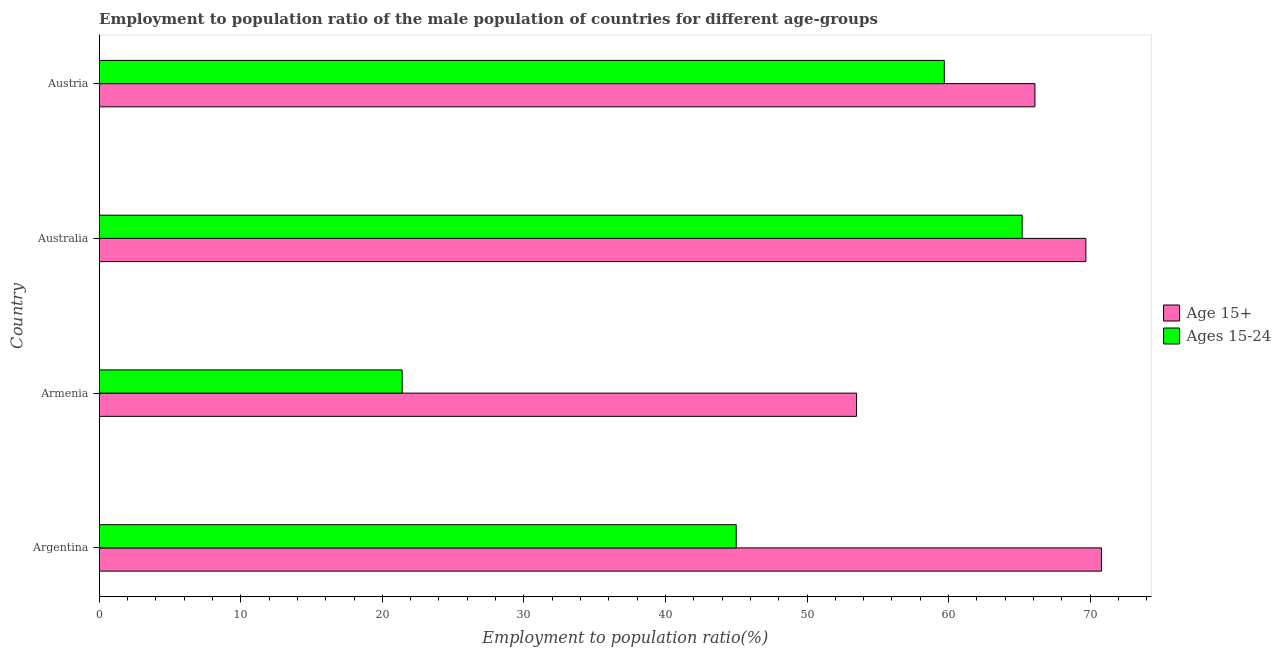Are the number of bars per tick equal to the number of legend labels?
Offer a terse response. Yes. What is the employment to population ratio(age 15-24) in Armenia?
Your answer should be compact. 21.4. Across all countries, what is the maximum employment to population ratio(age 15-24)?
Offer a very short reply. 65.2. Across all countries, what is the minimum employment to population ratio(age 15+)?
Your response must be concise. 53.5. In which country was the employment to population ratio(age 15-24) minimum?
Ensure brevity in your answer.  Armenia. What is the total employment to population ratio(age 15+) in the graph?
Ensure brevity in your answer.  260.1. What is the difference between the employment to population ratio(age 15+) in Armenia and that in Australia?
Give a very brief answer. -16.2. What is the average employment to population ratio(age 15-24) per country?
Offer a terse response. 47.83. What is the difference between the employment to population ratio(age 15-24) and employment to population ratio(age 15+) in Australia?
Your answer should be compact. -4.5. What is the ratio of the employment to population ratio(age 15-24) in Australia to that in Austria?
Provide a succinct answer. 1.09. Is the employment to population ratio(age 15-24) in Argentina less than that in Armenia?
Your answer should be compact. No. Is the difference between the employment to population ratio(age 15+) in Armenia and Australia greater than the difference between the employment to population ratio(age 15-24) in Armenia and Australia?
Your answer should be very brief. Yes. What is the difference between the highest and the second highest employment to population ratio(age 15+)?
Your answer should be compact. 1.1. What is the difference between the highest and the lowest employment to population ratio(age 15-24)?
Your answer should be very brief. 43.8. In how many countries, is the employment to population ratio(age 15-24) greater than the average employment to population ratio(age 15-24) taken over all countries?
Offer a very short reply. 2. Is the sum of the employment to population ratio(age 15+) in Argentina and Australia greater than the maximum employment to population ratio(age 15-24) across all countries?
Give a very brief answer. Yes. What does the 2nd bar from the top in Argentina represents?
Keep it short and to the point. Age 15+. What does the 2nd bar from the bottom in Argentina represents?
Keep it short and to the point. Ages 15-24. How many bars are there?
Your answer should be compact. 8. Are all the bars in the graph horizontal?
Your answer should be very brief. Yes. How many countries are there in the graph?
Your answer should be compact. 4. What is the difference between two consecutive major ticks on the X-axis?
Your response must be concise. 10. Are the values on the major ticks of X-axis written in scientific E-notation?
Your answer should be very brief. No. Does the graph contain any zero values?
Your answer should be very brief. No. Does the graph contain grids?
Ensure brevity in your answer.  No. How many legend labels are there?
Your answer should be very brief. 2. What is the title of the graph?
Your answer should be very brief. Employment to population ratio of the male population of countries for different age-groups. Does "Working capital" appear as one of the legend labels in the graph?
Your response must be concise. No. What is the label or title of the X-axis?
Your response must be concise. Employment to population ratio(%). What is the label or title of the Y-axis?
Make the answer very short. Country. What is the Employment to population ratio(%) in Age 15+ in Argentina?
Offer a very short reply. 70.8. What is the Employment to population ratio(%) in Ages 15-24 in Argentina?
Provide a short and direct response. 45. What is the Employment to population ratio(%) of Age 15+ in Armenia?
Give a very brief answer. 53.5. What is the Employment to population ratio(%) in Ages 15-24 in Armenia?
Make the answer very short. 21.4. What is the Employment to population ratio(%) of Age 15+ in Australia?
Make the answer very short. 69.7. What is the Employment to population ratio(%) in Ages 15-24 in Australia?
Ensure brevity in your answer.  65.2. What is the Employment to population ratio(%) in Age 15+ in Austria?
Your response must be concise. 66.1. What is the Employment to population ratio(%) of Ages 15-24 in Austria?
Your answer should be compact. 59.7. Across all countries, what is the maximum Employment to population ratio(%) in Age 15+?
Offer a terse response. 70.8. Across all countries, what is the maximum Employment to population ratio(%) in Ages 15-24?
Ensure brevity in your answer.  65.2. Across all countries, what is the minimum Employment to population ratio(%) in Age 15+?
Provide a succinct answer. 53.5. Across all countries, what is the minimum Employment to population ratio(%) of Ages 15-24?
Provide a short and direct response. 21.4. What is the total Employment to population ratio(%) in Age 15+ in the graph?
Provide a short and direct response. 260.1. What is the total Employment to population ratio(%) in Ages 15-24 in the graph?
Your response must be concise. 191.3. What is the difference between the Employment to population ratio(%) of Ages 15-24 in Argentina and that in Armenia?
Provide a short and direct response. 23.6. What is the difference between the Employment to population ratio(%) of Ages 15-24 in Argentina and that in Australia?
Keep it short and to the point. -20.2. What is the difference between the Employment to population ratio(%) of Age 15+ in Argentina and that in Austria?
Ensure brevity in your answer.  4.7. What is the difference between the Employment to population ratio(%) in Ages 15-24 in Argentina and that in Austria?
Provide a succinct answer. -14.7. What is the difference between the Employment to population ratio(%) of Age 15+ in Armenia and that in Australia?
Your answer should be very brief. -16.2. What is the difference between the Employment to population ratio(%) in Ages 15-24 in Armenia and that in Australia?
Keep it short and to the point. -43.8. What is the difference between the Employment to population ratio(%) of Age 15+ in Armenia and that in Austria?
Give a very brief answer. -12.6. What is the difference between the Employment to population ratio(%) in Ages 15-24 in Armenia and that in Austria?
Provide a succinct answer. -38.3. What is the difference between the Employment to population ratio(%) of Age 15+ in Argentina and the Employment to population ratio(%) of Ages 15-24 in Armenia?
Make the answer very short. 49.4. What is the difference between the Employment to population ratio(%) in Age 15+ in Armenia and the Employment to population ratio(%) in Ages 15-24 in Austria?
Provide a short and direct response. -6.2. What is the difference between the Employment to population ratio(%) in Age 15+ in Australia and the Employment to population ratio(%) in Ages 15-24 in Austria?
Keep it short and to the point. 10. What is the average Employment to population ratio(%) of Age 15+ per country?
Make the answer very short. 65.03. What is the average Employment to population ratio(%) in Ages 15-24 per country?
Give a very brief answer. 47.83. What is the difference between the Employment to population ratio(%) of Age 15+ and Employment to population ratio(%) of Ages 15-24 in Argentina?
Your response must be concise. 25.8. What is the difference between the Employment to population ratio(%) of Age 15+ and Employment to population ratio(%) of Ages 15-24 in Armenia?
Offer a very short reply. 32.1. What is the difference between the Employment to population ratio(%) in Age 15+ and Employment to population ratio(%) in Ages 15-24 in Austria?
Ensure brevity in your answer.  6.4. What is the ratio of the Employment to population ratio(%) in Age 15+ in Argentina to that in Armenia?
Give a very brief answer. 1.32. What is the ratio of the Employment to population ratio(%) of Ages 15-24 in Argentina to that in Armenia?
Provide a succinct answer. 2.1. What is the ratio of the Employment to population ratio(%) of Age 15+ in Argentina to that in Australia?
Offer a very short reply. 1.02. What is the ratio of the Employment to population ratio(%) of Ages 15-24 in Argentina to that in Australia?
Offer a very short reply. 0.69. What is the ratio of the Employment to population ratio(%) of Age 15+ in Argentina to that in Austria?
Offer a terse response. 1.07. What is the ratio of the Employment to population ratio(%) of Ages 15-24 in Argentina to that in Austria?
Make the answer very short. 0.75. What is the ratio of the Employment to population ratio(%) in Age 15+ in Armenia to that in Australia?
Your answer should be compact. 0.77. What is the ratio of the Employment to population ratio(%) of Ages 15-24 in Armenia to that in Australia?
Provide a short and direct response. 0.33. What is the ratio of the Employment to population ratio(%) of Age 15+ in Armenia to that in Austria?
Offer a terse response. 0.81. What is the ratio of the Employment to population ratio(%) in Ages 15-24 in Armenia to that in Austria?
Your response must be concise. 0.36. What is the ratio of the Employment to population ratio(%) in Age 15+ in Australia to that in Austria?
Your answer should be compact. 1.05. What is the ratio of the Employment to population ratio(%) in Ages 15-24 in Australia to that in Austria?
Keep it short and to the point. 1.09. What is the difference between the highest and the second highest Employment to population ratio(%) in Ages 15-24?
Ensure brevity in your answer.  5.5. What is the difference between the highest and the lowest Employment to population ratio(%) of Age 15+?
Provide a short and direct response. 17.3. What is the difference between the highest and the lowest Employment to population ratio(%) in Ages 15-24?
Ensure brevity in your answer.  43.8. 